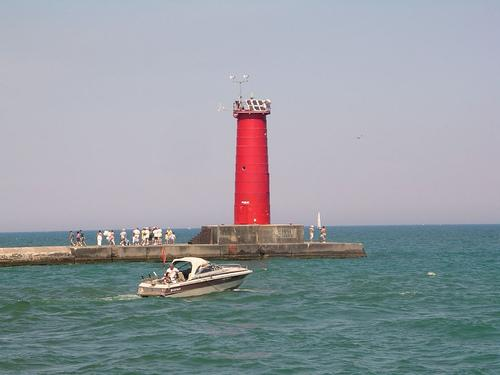What purpose does the red tower serve? Please explain your reasoning. warning ships. That is a lighthouse which helps ships see the shore. 